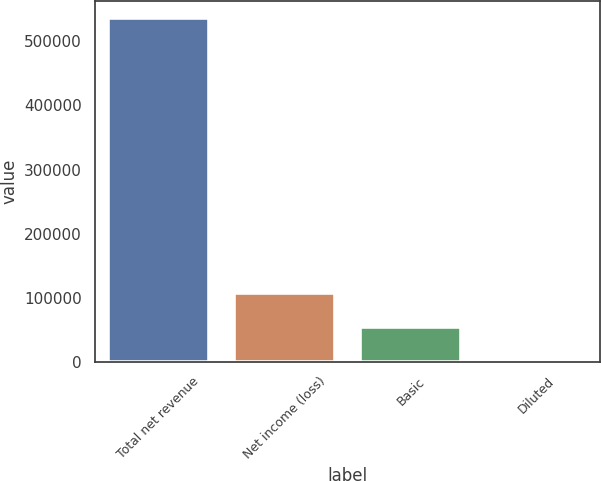Convert chart to OTSL. <chart><loc_0><loc_0><loc_500><loc_500><bar_chart><fcel>Total net revenue<fcel>Net income (loss)<fcel>Basic<fcel>Diluted<nl><fcel>536695<fcel>107339<fcel>53669.6<fcel>0.16<nl></chart> 